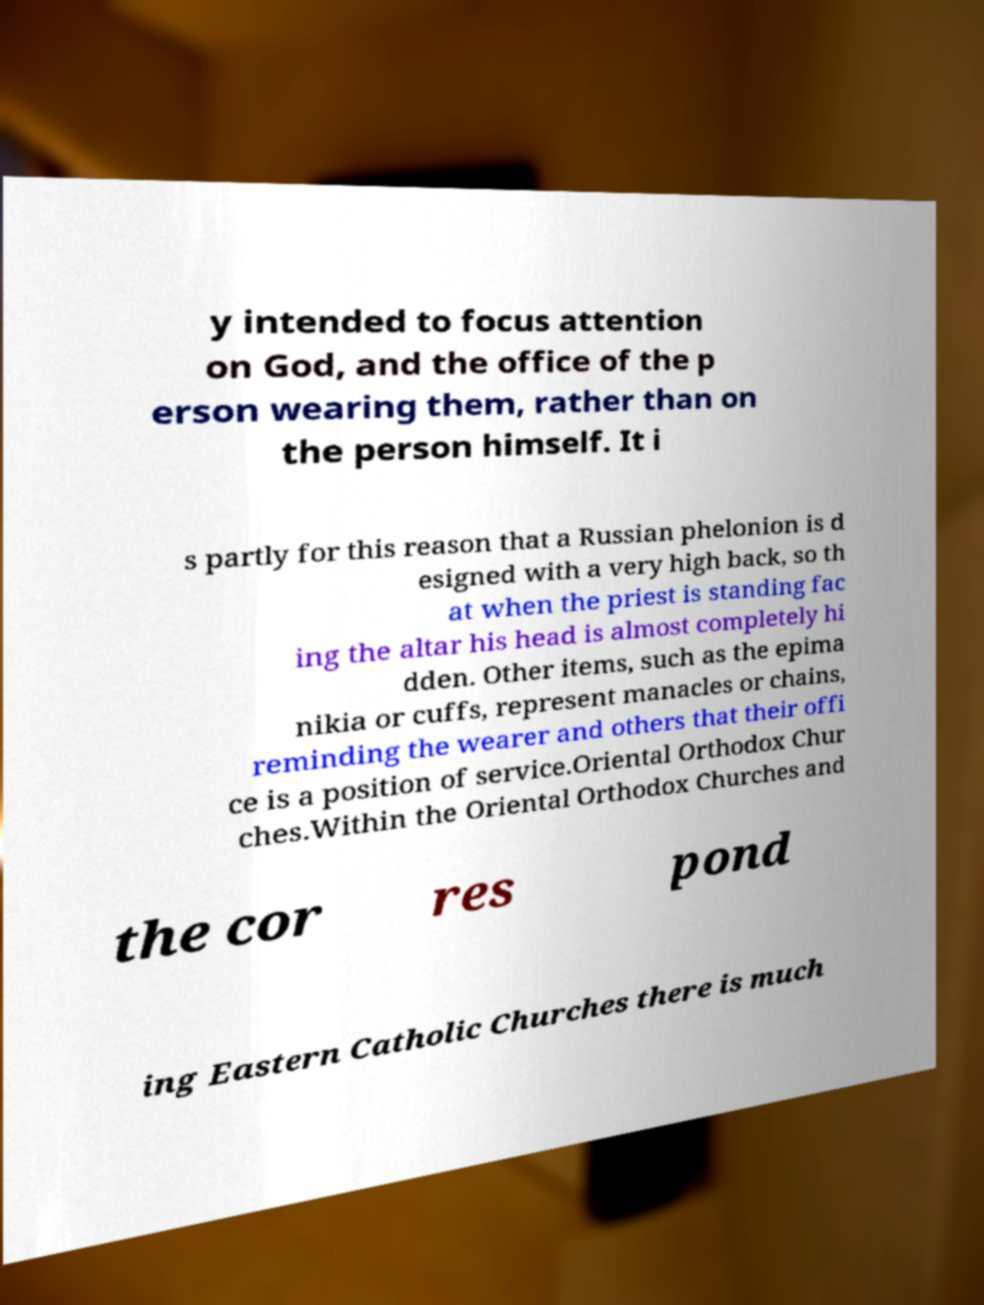Can you read and provide the text displayed in the image?This photo seems to have some interesting text. Can you extract and type it out for me? y intended to focus attention on God, and the office of the p erson wearing them, rather than on the person himself. It i s partly for this reason that a Russian phelonion is d esigned with a very high back, so th at when the priest is standing fac ing the altar his head is almost completely hi dden. Other items, such as the epima nikia or cuffs, represent manacles or chains, reminding the wearer and others that their offi ce is a position of service.Oriental Orthodox Chur ches.Within the Oriental Orthodox Churches and the cor res pond ing Eastern Catholic Churches there is much 